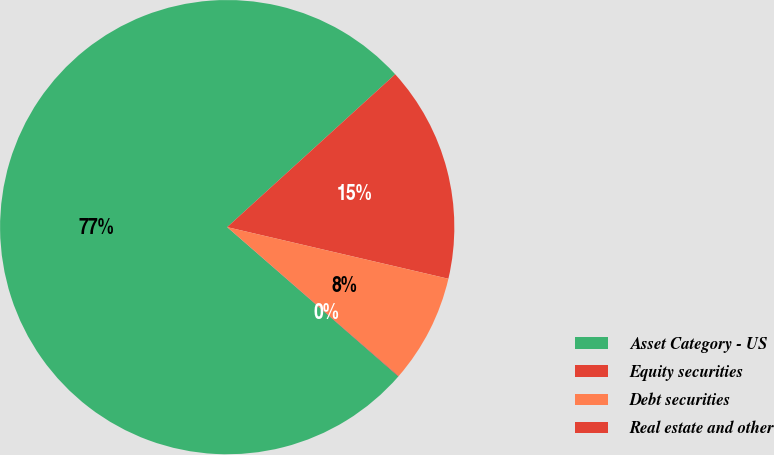<chart> <loc_0><loc_0><loc_500><loc_500><pie_chart><fcel>Asset Category - US<fcel>Equity securities<fcel>Debt securities<fcel>Real estate and other<nl><fcel>76.84%<fcel>15.4%<fcel>7.72%<fcel>0.04%<nl></chart> 